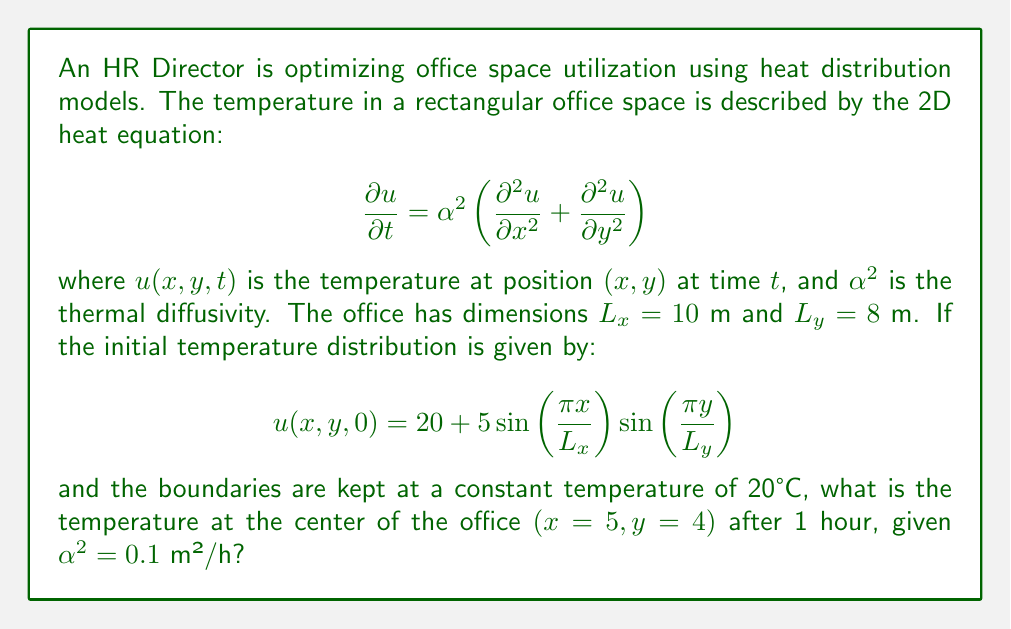Show me your answer to this math problem. To solve this problem, we'll use the separation of variables method for the 2D heat equation with the given initial and boundary conditions.

Step 1: The general solution for the 2D heat equation with the given boundary conditions is:

$$u(x,y,t) = 20 + \sum_{m=1}^{\infty}\sum_{n=1}^{\infty} A_{mn}\sin\left(\frac{m\pi x}{L_x}\right)\sin\left(\frac{n\pi y}{L_y}\right)e^{-\alpha^2(\frac{m^2\pi^2}{L_x^2}+\frac{n^2\pi^2}{L_y^2})t}$$

Step 2: Compare the initial condition with the general solution at $t=0$:

$$20 + 5\sin\left(\frac{\pi x}{L_x}\right)\sin\left(\frac{\pi y}{L_y}\right) = 20 + \sum_{m=1}^{\infty}\sum_{n=1}^{\infty} A_{mn}\sin\left(\frac{m\pi x}{L_x}\right)\sin\left(\frac{n\pi y}{L_y}\right)$$

Step 3: We can see that $A_{11} = 5$ and all other $A_{mn} = 0$. So, the solution simplifies to:

$$u(x,y,t) = 20 + 5\sin\left(\frac{\pi x}{L_x}\right)\sin\left(\frac{\pi y}{L_y}\right)e^{-\alpha^2(\frac{\pi^2}{L_x^2}+\frac{\pi^2}{L_y^2})t}$$

Step 4: Calculate the exponent:

$$\frac{\pi^2}{L_x^2}+\frac{\pi^2}{L_y^2} = \frac{\pi^2}{10^2}+\frac{\pi^2}{8^2} = 0.0987 + 0.1543 = 0.2530$$

Step 5: Substitute the values for the center of the office $(x=5, y=4)$ and $t=1$ hour:

$$u(5,4,1) = 20 + 5\sin\left(\frac{\pi \cdot 5}{10}\right)\sin\left(\frac{\pi \cdot 4}{8}\right)e^{-0.1 \cdot 0.2530 \cdot 1}$$

Step 6: Calculate the result:

$$u(5,4,1) = 20 + 5 \cdot 1 \cdot 1 \cdot e^{-0.02530} = 20 + 5 \cdot 0.9750 = 24.875°C$$
Answer: 24.875°C 